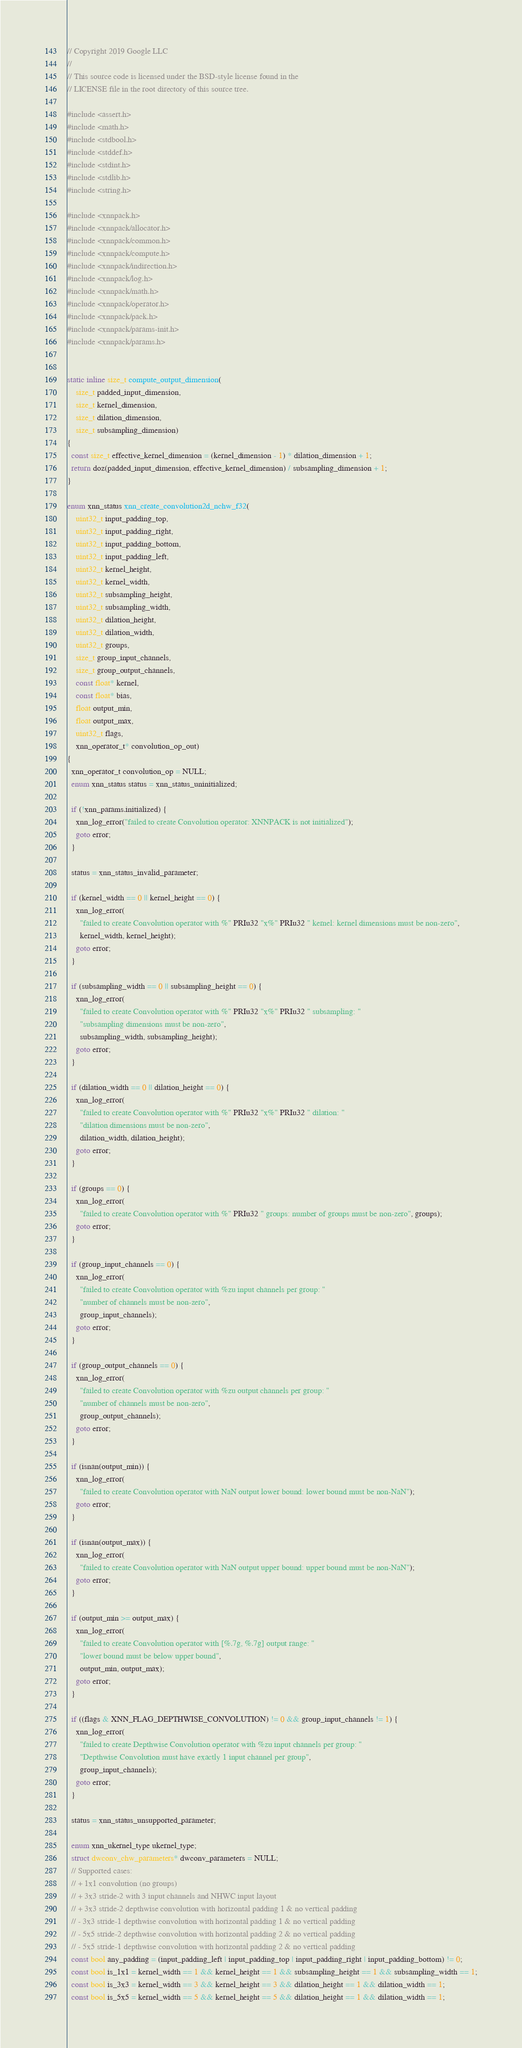Convert code to text. <code><loc_0><loc_0><loc_500><loc_500><_C_>// Copyright 2019 Google LLC
//
// This source code is licensed under the BSD-style license found in the
// LICENSE file in the root directory of this source tree.

#include <assert.h>
#include <math.h>
#include <stdbool.h>
#include <stddef.h>
#include <stdint.h>
#include <stdlib.h>
#include <string.h>

#include <xnnpack.h>
#include <xnnpack/allocator.h>
#include <xnnpack/common.h>
#include <xnnpack/compute.h>
#include <xnnpack/indirection.h>
#include <xnnpack/log.h>
#include <xnnpack/math.h>
#include <xnnpack/operator.h>
#include <xnnpack/pack.h>
#include <xnnpack/params-init.h>
#include <xnnpack/params.h>


static inline size_t compute_output_dimension(
    size_t padded_input_dimension,
    size_t kernel_dimension,
    size_t dilation_dimension,
    size_t subsampling_dimension)
{
  const size_t effective_kernel_dimension = (kernel_dimension - 1) * dilation_dimension + 1;
  return doz(padded_input_dimension, effective_kernel_dimension) / subsampling_dimension + 1;
}

enum xnn_status xnn_create_convolution2d_nchw_f32(
    uint32_t input_padding_top,
    uint32_t input_padding_right,
    uint32_t input_padding_bottom,
    uint32_t input_padding_left,
    uint32_t kernel_height,
    uint32_t kernel_width,
    uint32_t subsampling_height,
    uint32_t subsampling_width,
    uint32_t dilation_height,
    uint32_t dilation_width,
    uint32_t groups,
    size_t group_input_channels,
    size_t group_output_channels,
    const float* kernel,
    const float* bias,
    float output_min,
    float output_max,
    uint32_t flags,
    xnn_operator_t* convolution_op_out)
{
  xnn_operator_t convolution_op = NULL;
  enum xnn_status status = xnn_status_uninitialized;

  if (!xnn_params.initialized) {
    xnn_log_error("failed to create Convolution operator: XNNPACK is not initialized");
    goto error;
  }

  status = xnn_status_invalid_parameter;

  if (kernel_width == 0 || kernel_height == 0) {
    xnn_log_error(
      "failed to create Convolution operator with %" PRIu32 "x%" PRIu32 " kernel: kernel dimensions must be non-zero",
      kernel_width, kernel_height);
    goto error;
  }

  if (subsampling_width == 0 || subsampling_height == 0) {
    xnn_log_error(
      "failed to create Convolution operator with %" PRIu32 "x%" PRIu32 " subsampling: "
      "subsampling dimensions must be non-zero",
      subsampling_width, subsampling_height);
    goto error;
  }

  if (dilation_width == 0 || dilation_height == 0) {
    xnn_log_error(
      "failed to create Convolution operator with %" PRIu32 "x%" PRIu32 " dilation: "
      "dilation dimensions must be non-zero",
      dilation_width, dilation_height);
    goto error;
  }

  if (groups == 0) {
    xnn_log_error(
      "failed to create Convolution operator with %" PRIu32 " groups: number of groups must be non-zero", groups);
    goto error;
  }

  if (group_input_channels == 0) {
    xnn_log_error(
      "failed to create Convolution operator with %zu input channels per group: "
      "number of channels must be non-zero",
      group_input_channels);
    goto error;
  }

  if (group_output_channels == 0) {
    xnn_log_error(
      "failed to create Convolution operator with %zu output channels per group: "
      "number of channels must be non-zero",
      group_output_channels);
    goto error;
  }

  if (isnan(output_min)) {
    xnn_log_error(
      "failed to create Convolution operator with NaN output lower bound: lower bound must be non-NaN");
    goto error;
  }

  if (isnan(output_max)) {
    xnn_log_error(
      "failed to create Convolution operator with NaN output upper bound: upper bound must be non-NaN");
    goto error;
  }

  if (output_min >= output_max) {
    xnn_log_error(
      "failed to create Convolution operator with [%.7g, %.7g] output range: "
      "lower bound must be below upper bound",
      output_min, output_max);
    goto error;
  }

  if ((flags & XNN_FLAG_DEPTHWISE_CONVOLUTION) != 0 && group_input_channels != 1) {
    xnn_log_error(
      "failed to create Depthwise Convolution operator with %zu input channels per group: "
      "Depthwise Convolution must have exactly 1 input channel per group",
      group_input_channels);
    goto error;
  }

  status = xnn_status_unsupported_parameter;

  enum xnn_ukernel_type ukernel_type;
  struct dwconv_chw_parameters* dwconv_parameters = NULL;
  // Supported cases:
  // + 1x1 convolution (no groups)
  // + 3x3 stride-2 with 3 input channels and NHWC input layout
  // + 3x3 stride-2 depthwise convolution with horizontal padding 1 & no vertical padding
  // - 3x3 stride-1 depthwise convolution with horizontal padding 1 & no vertical padding
  // - 5x5 stride-2 depthwise convolution with horizontal padding 2 & no vertical padding
  // - 5x5 stride-1 depthwise convolution with horizontal padding 2 & no vertical padding
  const bool any_padding = (input_padding_left | input_padding_top | input_padding_right | input_padding_bottom) != 0;
  const bool is_1x1 = kernel_width == 1 && kernel_height == 1 && subsampling_height == 1 && subsampling_width == 1;
  const bool is_3x3 = kernel_width == 3 && kernel_height == 3 && dilation_height == 1 && dilation_width == 1;
  const bool is_5x5 = kernel_width == 5 && kernel_height == 5 && dilation_height == 1 && dilation_width == 1;</code> 